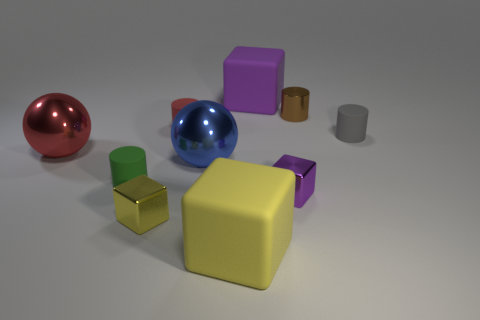Subtract all balls. How many objects are left? 8 Subtract 1 blue spheres. How many objects are left? 9 Subtract all large gray balls. Subtract all tiny gray rubber cylinders. How many objects are left? 9 Add 2 red rubber cylinders. How many red rubber cylinders are left? 3 Add 2 tiny purple metal things. How many tiny purple metal things exist? 3 